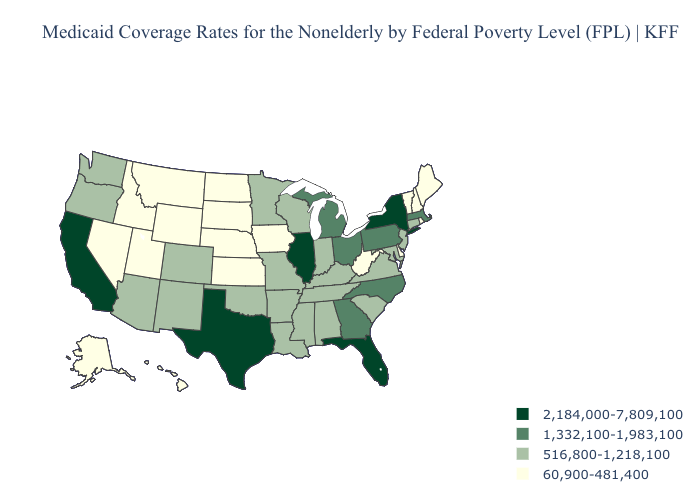What is the value of Georgia?
Short answer required. 1,332,100-1,983,100. What is the value of Wisconsin?
Keep it brief. 516,800-1,218,100. What is the highest value in states that border Tennessee?
Be succinct. 1,332,100-1,983,100. What is the value of Kansas?
Write a very short answer. 60,900-481,400. Does Delaware have the highest value in the USA?
Give a very brief answer. No. What is the highest value in the USA?
Concise answer only. 2,184,000-7,809,100. What is the highest value in states that border Mississippi?
Write a very short answer. 516,800-1,218,100. Which states hav the highest value in the Northeast?
Give a very brief answer. New York. What is the highest value in states that border Minnesota?
Quick response, please. 516,800-1,218,100. Name the states that have a value in the range 2,184,000-7,809,100?
Quick response, please. California, Florida, Illinois, New York, Texas. Is the legend a continuous bar?
Answer briefly. No. Which states have the lowest value in the USA?
Write a very short answer. Alaska, Delaware, Hawaii, Idaho, Iowa, Kansas, Maine, Montana, Nebraska, Nevada, New Hampshire, North Dakota, Rhode Island, South Dakota, Utah, Vermont, West Virginia, Wyoming. Name the states that have a value in the range 2,184,000-7,809,100?
Be succinct. California, Florida, Illinois, New York, Texas. Among the states that border Arizona , which have the highest value?
Be succinct. California. What is the lowest value in the USA?
Concise answer only. 60,900-481,400. 